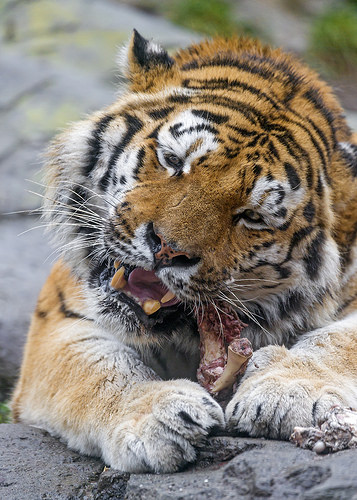<image>
Is there a flesh on the tiger? No. The flesh is not positioned on the tiger. They may be near each other, but the flesh is not supported by or resting on top of the tiger. Where is the meat in relation to the tiger? Is it behind the tiger? No. The meat is not behind the tiger. From this viewpoint, the meat appears to be positioned elsewhere in the scene. 